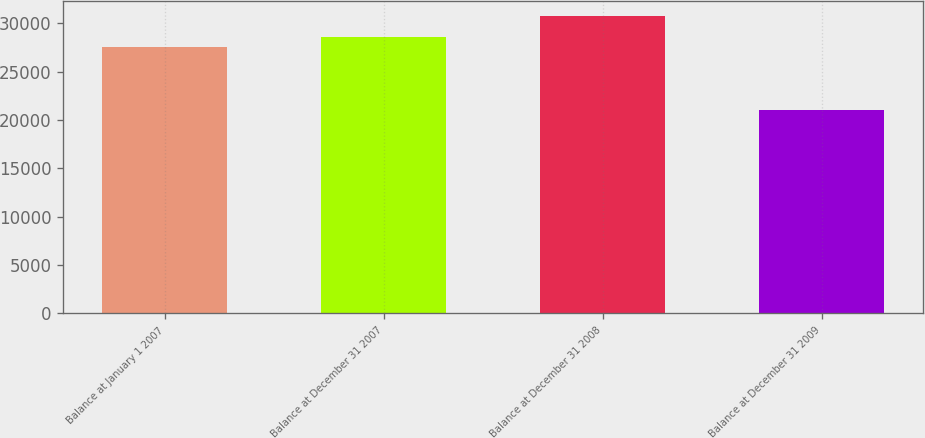Convert chart to OTSL. <chart><loc_0><loc_0><loc_500><loc_500><bar_chart><fcel>Balance at January 1 2007<fcel>Balance at December 31 2007<fcel>Balance at December 31 2008<fcel>Balance at December 31 2009<nl><fcel>27567.4<fcel>28536.5<fcel>30735.5<fcel>21044.3<nl></chart> 